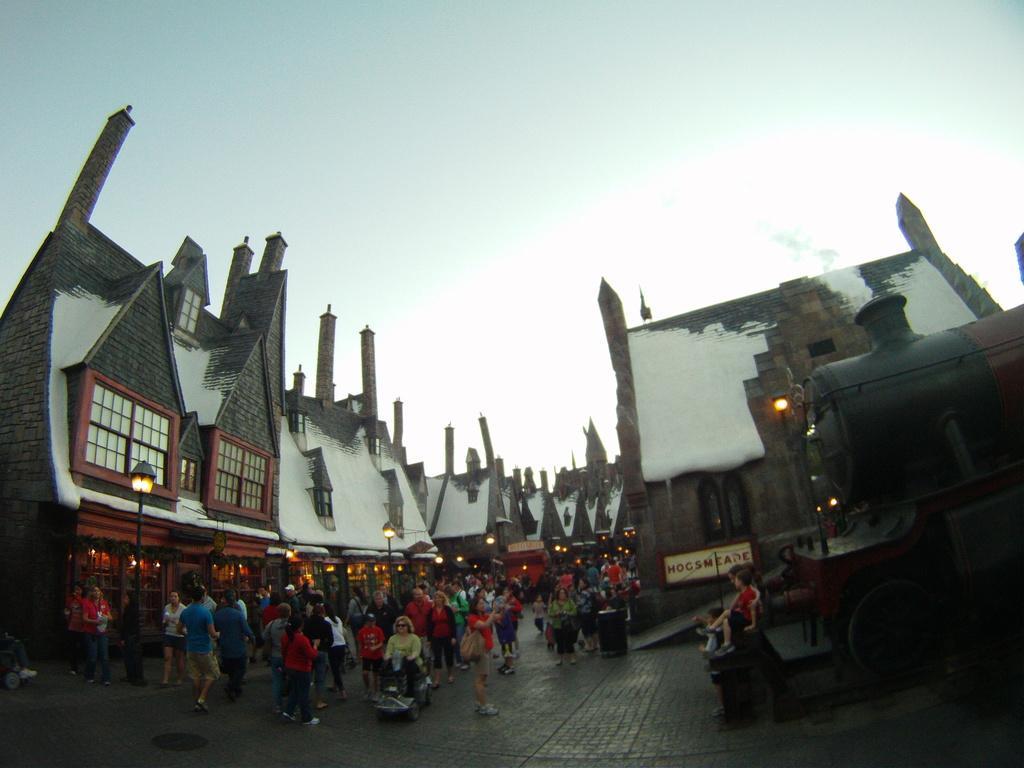In one or two sentences, can you explain what this image depicts? In this image there are persons standing walking and sitting. In the background there are houses, poles and the sky is cloudy. On the right side there is a rail engine and there is a smoke coming from it. 